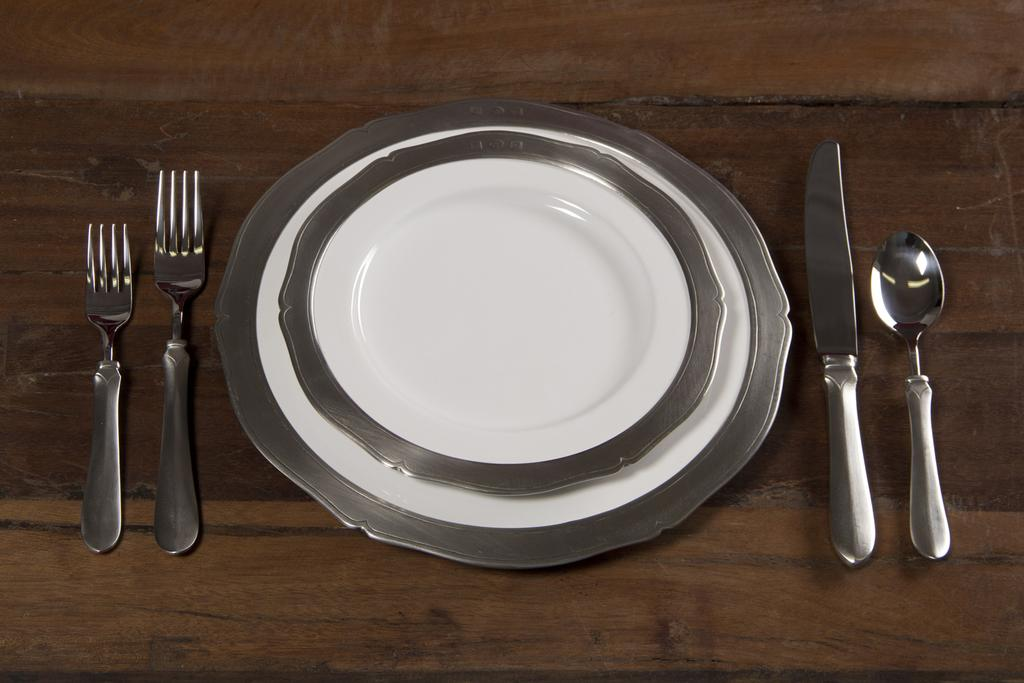How many plates are visible in the image? There are two plates in the image. What is the surface made of that the plates are placed on? The plates are placed on a wooden surface. What utensils are present in the image? There are two forks, a knife, and a spoon in the image. What might the wooden surface be used for? The wooden surface is likely a table or countertop, which could be used for dining or food preparation. What type of club does the deer belong to in the image? There is no club or deer present in the image; it features two plates, a wooden surface, and various utensils. 